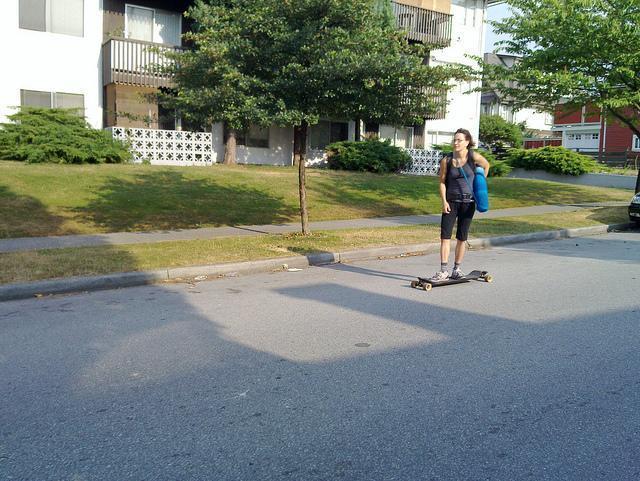How many brown horses are in the grass?
Give a very brief answer. 0. 